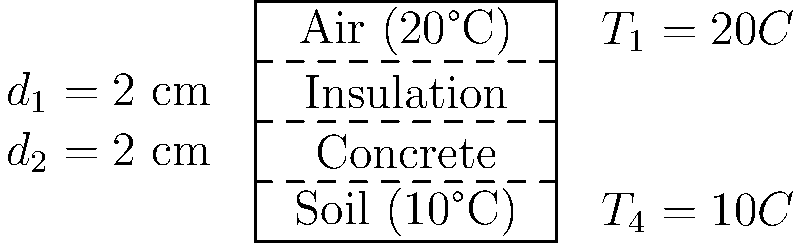An animal enclosure has a layered floor consisting of air, insulation, and concrete, as shown in the diagram. The air temperature inside the enclosure is 20°C, and the soil temperature beneath the concrete is 10°C. The insulation layer and concrete layer each have a thickness of 2 cm. If the thermal conductivity of the insulation is 0.04 W/(m·K) and that of concrete is 1.7 W/(m·K), calculate the rate of heat transfer per square meter through the floor of the enclosure. To solve this problem, we'll use the concept of thermal resistance in series and Fourier's law of heat conduction. Let's follow these steps:

1) The total thermal resistance is the sum of the resistances of each layer:
   $R_{total} = R_{insulation} + R_{concrete}$

2) Thermal resistance is given by $R = \frac{d}{k}$, where $d$ is thickness and $k$ is thermal conductivity:
   $R_{insulation} = \frac{0.02 \text{ m}}{0.04 \text{ W/(m·K)}} = 0.5 \text{ m²K/W}$
   $R_{concrete} = \frac{0.02 \text{ m}}{1.7 \text{ W/(m·K)}} = 0.0118 \text{ m²K/W}$

3) Total thermal resistance:
   $R_{total} = 0.5 + 0.0118 = 0.5118 \text{ m²K/W}$

4) The rate of heat transfer is given by $q = \frac{\Delta T}{R_{total}}$, where $\Delta T$ is the temperature difference:
   $q = \frac{20°C - 10°C}{0.5118 \text{ m²K/W}} = \frac{10 \text{ K}}{0.5118 \text{ m²K/W}}$

5) Calculate the final result:
   $q = 19.54 \text{ W/m²}$

Therefore, the rate of heat transfer through the floor is approximately 19.54 W/m².
Answer: 19.54 W/m² 